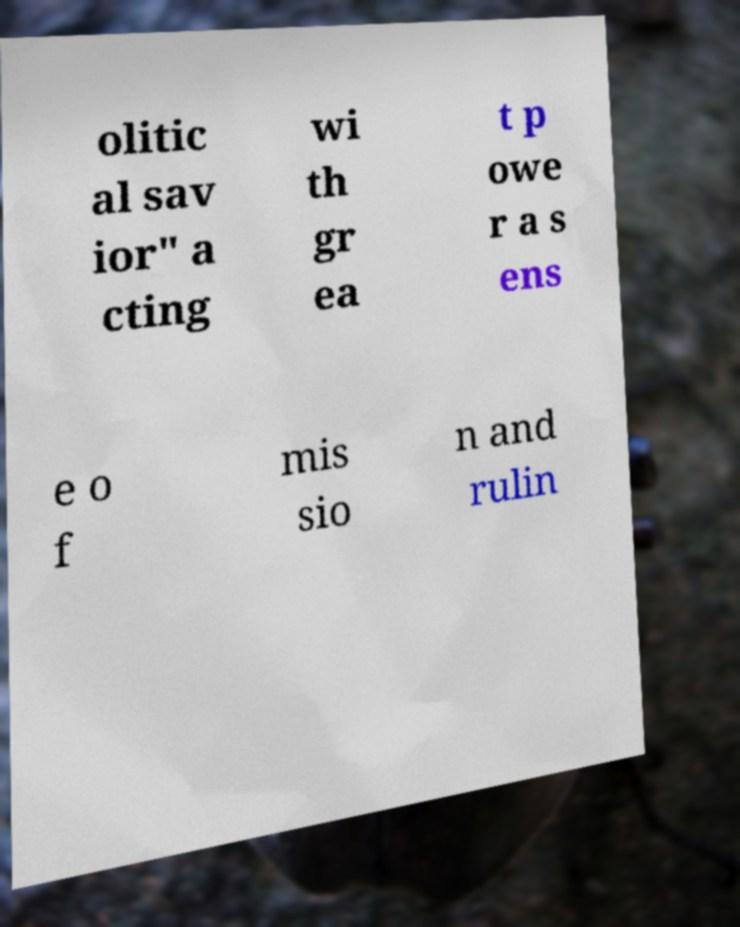Can you read and provide the text displayed in the image?This photo seems to have some interesting text. Can you extract and type it out for me? olitic al sav ior" a cting wi th gr ea t p owe r a s ens e o f mis sio n and rulin 